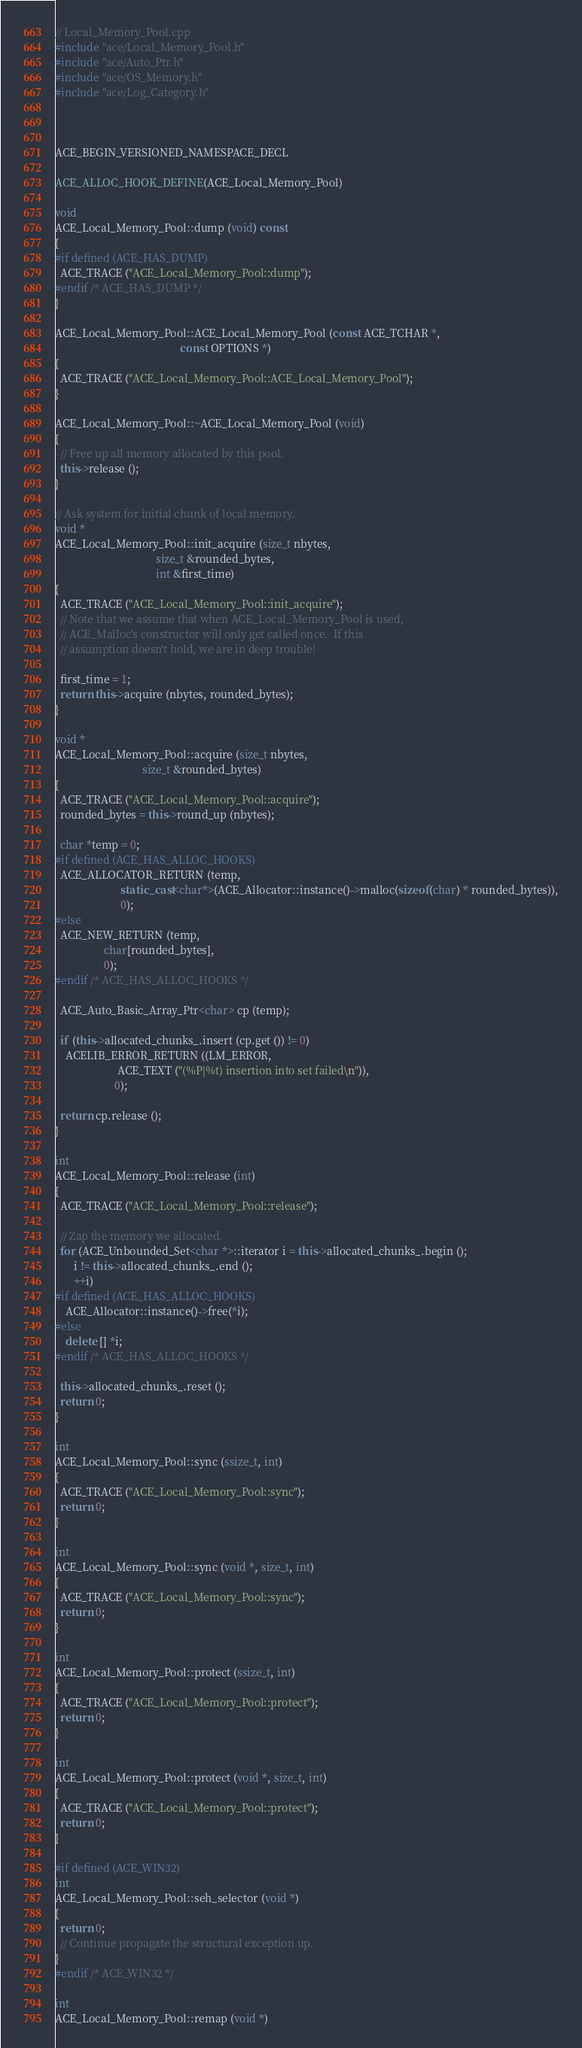<code> <loc_0><loc_0><loc_500><loc_500><_C++_>// Local_Memory_Pool.cpp
#include "ace/Local_Memory_Pool.h"
#include "ace/Auto_Ptr.h"
#include "ace/OS_Memory.h"
#include "ace/Log_Category.h"



ACE_BEGIN_VERSIONED_NAMESPACE_DECL

ACE_ALLOC_HOOK_DEFINE(ACE_Local_Memory_Pool)

void
ACE_Local_Memory_Pool::dump (void) const
{
#if defined (ACE_HAS_DUMP)
  ACE_TRACE ("ACE_Local_Memory_Pool::dump");
#endif /* ACE_HAS_DUMP */
}

ACE_Local_Memory_Pool::ACE_Local_Memory_Pool (const ACE_TCHAR *,
                                              const OPTIONS *)
{
  ACE_TRACE ("ACE_Local_Memory_Pool::ACE_Local_Memory_Pool");
}

ACE_Local_Memory_Pool::~ACE_Local_Memory_Pool (void)
{
  // Free up all memory allocated by this pool.
  this->release ();
}

// Ask system for initial chunk of local memory.
void *
ACE_Local_Memory_Pool::init_acquire (size_t nbytes,
                                     size_t &rounded_bytes,
                                     int &first_time)
{
  ACE_TRACE ("ACE_Local_Memory_Pool::init_acquire");
  // Note that we assume that when ACE_Local_Memory_Pool is used,
  // ACE_Malloc's constructor will only get called once.  If this
  // assumption doesn't hold, we are in deep trouble!

  first_time = 1;
  return this->acquire (nbytes, rounded_bytes);
}

void *
ACE_Local_Memory_Pool::acquire (size_t nbytes,
                                size_t &rounded_bytes)
{
  ACE_TRACE ("ACE_Local_Memory_Pool::acquire");
  rounded_bytes = this->round_up (nbytes);

  char *temp = 0;
#if defined (ACE_HAS_ALLOC_HOOKS)
  ACE_ALLOCATOR_RETURN (temp,
                        static_cast<char*>(ACE_Allocator::instance()->malloc(sizeof(char) * rounded_bytes)),
                        0);
#else
  ACE_NEW_RETURN (temp,
                  char[rounded_bytes],
                  0);
#endif /* ACE_HAS_ALLOC_HOOKS */

  ACE_Auto_Basic_Array_Ptr<char> cp (temp);

  if (this->allocated_chunks_.insert (cp.get ()) != 0)
    ACELIB_ERROR_RETURN ((LM_ERROR,
                       ACE_TEXT ("(%P|%t) insertion into set failed\n")),
                      0);

  return cp.release ();
}

int
ACE_Local_Memory_Pool::release (int)
{
  ACE_TRACE ("ACE_Local_Memory_Pool::release");

  // Zap the memory we allocated.
  for (ACE_Unbounded_Set<char *>::iterator i = this->allocated_chunks_.begin ();
       i != this->allocated_chunks_.end ();
       ++i)
#if defined (ACE_HAS_ALLOC_HOOKS)
    ACE_Allocator::instance()->free(*i);
#else
    delete [] *i;
#endif /* ACE_HAS_ALLOC_HOOKS */

  this->allocated_chunks_.reset ();
  return 0;
}

int
ACE_Local_Memory_Pool::sync (ssize_t, int)
{
  ACE_TRACE ("ACE_Local_Memory_Pool::sync");
  return 0;
}

int
ACE_Local_Memory_Pool::sync (void *, size_t, int)
{
  ACE_TRACE ("ACE_Local_Memory_Pool::sync");
  return 0;
}

int
ACE_Local_Memory_Pool::protect (ssize_t, int)
{
  ACE_TRACE ("ACE_Local_Memory_Pool::protect");
  return 0;
}

int
ACE_Local_Memory_Pool::protect (void *, size_t, int)
{
  ACE_TRACE ("ACE_Local_Memory_Pool::protect");
  return 0;
}

#if defined (ACE_WIN32)
int
ACE_Local_Memory_Pool::seh_selector (void *)
{
  return 0;
  // Continue propagate the structural exception up.
}
#endif /* ACE_WIN32 */

int
ACE_Local_Memory_Pool::remap (void *)</code> 